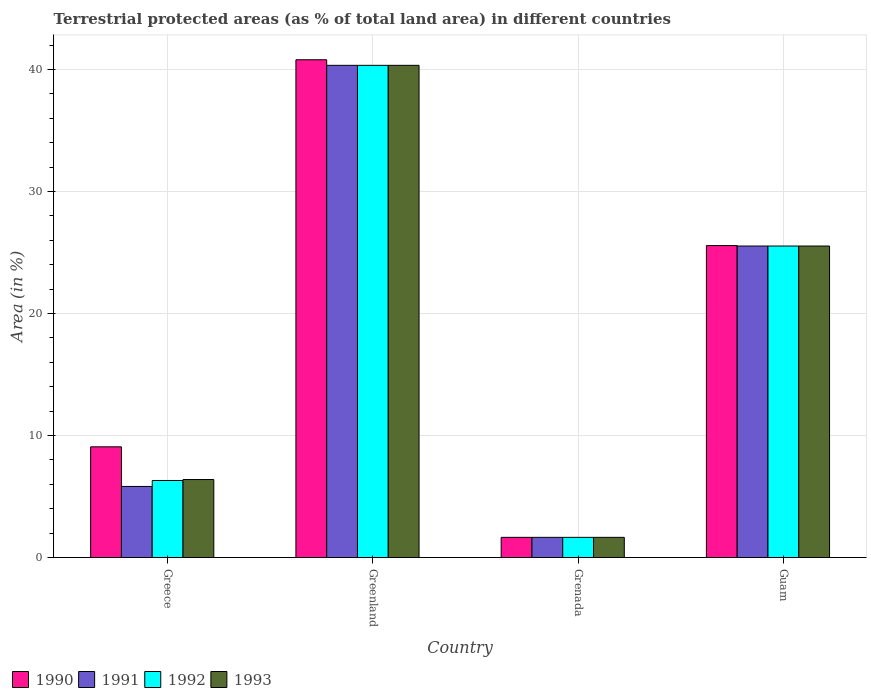How many different coloured bars are there?
Your response must be concise. 4. Are the number of bars per tick equal to the number of legend labels?
Provide a succinct answer. Yes. What is the label of the 4th group of bars from the left?
Your answer should be very brief. Guam. In how many cases, is the number of bars for a given country not equal to the number of legend labels?
Give a very brief answer. 0. What is the percentage of terrestrial protected land in 1993 in Greenland?
Offer a terse response. 40.35. Across all countries, what is the maximum percentage of terrestrial protected land in 1990?
Your answer should be very brief. 40.81. Across all countries, what is the minimum percentage of terrestrial protected land in 1991?
Offer a very short reply. 1.66. In which country was the percentage of terrestrial protected land in 1993 maximum?
Offer a terse response. Greenland. In which country was the percentage of terrestrial protected land in 1993 minimum?
Give a very brief answer. Grenada. What is the total percentage of terrestrial protected land in 1993 in the graph?
Make the answer very short. 73.94. What is the difference between the percentage of terrestrial protected land in 1991 in Greece and that in Greenland?
Offer a very short reply. -34.52. What is the difference between the percentage of terrestrial protected land in 1990 in Greece and the percentage of terrestrial protected land in 1992 in Greenland?
Provide a short and direct response. -31.27. What is the average percentage of terrestrial protected land in 1992 per country?
Make the answer very short. 18.46. What is the difference between the percentage of terrestrial protected land of/in 1993 and percentage of terrestrial protected land of/in 1992 in Guam?
Provide a succinct answer. 0. What is the ratio of the percentage of terrestrial protected land in 1991 in Greece to that in Greenland?
Ensure brevity in your answer.  0.14. What is the difference between the highest and the second highest percentage of terrestrial protected land in 1993?
Offer a terse response. 14.81. What is the difference between the highest and the lowest percentage of terrestrial protected land in 1993?
Provide a succinct answer. 38.69. What does the 1st bar from the left in Greece represents?
Your answer should be compact. 1990. What does the 4th bar from the right in Greece represents?
Your answer should be compact. 1990. Is it the case that in every country, the sum of the percentage of terrestrial protected land in 1990 and percentage of terrestrial protected land in 1993 is greater than the percentage of terrestrial protected land in 1992?
Offer a very short reply. Yes. How many bars are there?
Ensure brevity in your answer.  16. Are all the bars in the graph horizontal?
Offer a very short reply. No. Where does the legend appear in the graph?
Ensure brevity in your answer.  Bottom left. How are the legend labels stacked?
Provide a short and direct response. Horizontal. What is the title of the graph?
Offer a terse response. Terrestrial protected areas (as % of total land area) in different countries. Does "1965" appear as one of the legend labels in the graph?
Your answer should be very brief. No. What is the label or title of the X-axis?
Give a very brief answer. Country. What is the label or title of the Y-axis?
Make the answer very short. Area (in %). What is the Area (in %) of 1990 in Greece?
Your answer should be compact. 9.08. What is the Area (in %) in 1991 in Greece?
Provide a short and direct response. 5.83. What is the Area (in %) in 1992 in Greece?
Make the answer very short. 6.32. What is the Area (in %) of 1993 in Greece?
Make the answer very short. 6.4. What is the Area (in %) in 1990 in Greenland?
Your answer should be very brief. 40.81. What is the Area (in %) of 1991 in Greenland?
Offer a terse response. 40.35. What is the Area (in %) in 1992 in Greenland?
Offer a terse response. 40.35. What is the Area (in %) of 1993 in Greenland?
Your response must be concise. 40.35. What is the Area (in %) of 1990 in Grenada?
Keep it short and to the point. 1.66. What is the Area (in %) of 1991 in Grenada?
Your answer should be compact. 1.66. What is the Area (in %) in 1992 in Grenada?
Keep it short and to the point. 1.66. What is the Area (in %) in 1993 in Grenada?
Make the answer very short. 1.66. What is the Area (in %) in 1990 in Guam?
Your response must be concise. 25.57. What is the Area (in %) in 1991 in Guam?
Offer a very short reply. 25.54. What is the Area (in %) of 1992 in Guam?
Provide a short and direct response. 25.54. What is the Area (in %) in 1993 in Guam?
Provide a succinct answer. 25.54. Across all countries, what is the maximum Area (in %) in 1990?
Keep it short and to the point. 40.81. Across all countries, what is the maximum Area (in %) of 1991?
Your response must be concise. 40.35. Across all countries, what is the maximum Area (in %) in 1992?
Give a very brief answer. 40.35. Across all countries, what is the maximum Area (in %) of 1993?
Your response must be concise. 40.35. Across all countries, what is the minimum Area (in %) in 1990?
Your response must be concise. 1.66. Across all countries, what is the minimum Area (in %) in 1991?
Offer a very short reply. 1.66. Across all countries, what is the minimum Area (in %) in 1992?
Your answer should be very brief. 1.66. Across all countries, what is the minimum Area (in %) in 1993?
Your answer should be very brief. 1.66. What is the total Area (in %) in 1990 in the graph?
Offer a very short reply. 77.11. What is the total Area (in %) of 1991 in the graph?
Your response must be concise. 73.37. What is the total Area (in %) of 1992 in the graph?
Your answer should be very brief. 73.86. What is the total Area (in %) of 1993 in the graph?
Keep it short and to the point. 73.94. What is the difference between the Area (in %) in 1990 in Greece and that in Greenland?
Your answer should be very brief. -31.73. What is the difference between the Area (in %) of 1991 in Greece and that in Greenland?
Give a very brief answer. -34.52. What is the difference between the Area (in %) of 1992 in Greece and that in Greenland?
Keep it short and to the point. -34.03. What is the difference between the Area (in %) in 1993 in Greece and that in Greenland?
Offer a terse response. -33.95. What is the difference between the Area (in %) in 1990 in Greece and that in Grenada?
Ensure brevity in your answer.  7.42. What is the difference between the Area (in %) of 1991 in Greece and that in Grenada?
Your answer should be very brief. 4.17. What is the difference between the Area (in %) of 1992 in Greece and that in Grenada?
Make the answer very short. 4.66. What is the difference between the Area (in %) of 1993 in Greece and that in Grenada?
Provide a short and direct response. 4.74. What is the difference between the Area (in %) in 1990 in Greece and that in Guam?
Keep it short and to the point. -16.5. What is the difference between the Area (in %) in 1991 in Greece and that in Guam?
Offer a terse response. -19.71. What is the difference between the Area (in %) of 1992 in Greece and that in Guam?
Provide a short and direct response. -19.22. What is the difference between the Area (in %) in 1993 in Greece and that in Guam?
Offer a very short reply. -19.14. What is the difference between the Area (in %) in 1990 in Greenland and that in Grenada?
Provide a short and direct response. 39.15. What is the difference between the Area (in %) in 1991 in Greenland and that in Grenada?
Ensure brevity in your answer.  38.69. What is the difference between the Area (in %) of 1992 in Greenland and that in Grenada?
Your answer should be compact. 38.69. What is the difference between the Area (in %) in 1993 in Greenland and that in Grenada?
Make the answer very short. 38.69. What is the difference between the Area (in %) of 1990 in Greenland and that in Guam?
Your answer should be very brief. 15.23. What is the difference between the Area (in %) of 1991 in Greenland and that in Guam?
Your answer should be very brief. 14.81. What is the difference between the Area (in %) of 1992 in Greenland and that in Guam?
Offer a very short reply. 14.81. What is the difference between the Area (in %) in 1993 in Greenland and that in Guam?
Keep it short and to the point. 14.81. What is the difference between the Area (in %) in 1990 in Grenada and that in Guam?
Offer a very short reply. -23.92. What is the difference between the Area (in %) in 1991 in Grenada and that in Guam?
Your answer should be compact. -23.88. What is the difference between the Area (in %) in 1992 in Grenada and that in Guam?
Your answer should be compact. -23.88. What is the difference between the Area (in %) in 1993 in Grenada and that in Guam?
Provide a short and direct response. -23.88. What is the difference between the Area (in %) of 1990 in Greece and the Area (in %) of 1991 in Greenland?
Give a very brief answer. -31.27. What is the difference between the Area (in %) of 1990 in Greece and the Area (in %) of 1992 in Greenland?
Your response must be concise. -31.27. What is the difference between the Area (in %) in 1990 in Greece and the Area (in %) in 1993 in Greenland?
Provide a succinct answer. -31.27. What is the difference between the Area (in %) in 1991 in Greece and the Area (in %) in 1992 in Greenland?
Your answer should be very brief. -34.52. What is the difference between the Area (in %) in 1991 in Greece and the Area (in %) in 1993 in Greenland?
Your answer should be very brief. -34.52. What is the difference between the Area (in %) of 1992 in Greece and the Area (in %) of 1993 in Greenland?
Give a very brief answer. -34.03. What is the difference between the Area (in %) of 1990 in Greece and the Area (in %) of 1991 in Grenada?
Offer a very short reply. 7.42. What is the difference between the Area (in %) of 1990 in Greece and the Area (in %) of 1992 in Grenada?
Provide a short and direct response. 7.42. What is the difference between the Area (in %) of 1990 in Greece and the Area (in %) of 1993 in Grenada?
Provide a short and direct response. 7.42. What is the difference between the Area (in %) in 1991 in Greece and the Area (in %) in 1992 in Grenada?
Provide a short and direct response. 4.17. What is the difference between the Area (in %) in 1991 in Greece and the Area (in %) in 1993 in Grenada?
Offer a terse response. 4.17. What is the difference between the Area (in %) in 1992 in Greece and the Area (in %) in 1993 in Grenada?
Your answer should be compact. 4.66. What is the difference between the Area (in %) in 1990 in Greece and the Area (in %) in 1991 in Guam?
Ensure brevity in your answer.  -16.46. What is the difference between the Area (in %) of 1990 in Greece and the Area (in %) of 1992 in Guam?
Offer a terse response. -16.46. What is the difference between the Area (in %) of 1990 in Greece and the Area (in %) of 1993 in Guam?
Provide a succinct answer. -16.46. What is the difference between the Area (in %) in 1991 in Greece and the Area (in %) in 1992 in Guam?
Your answer should be very brief. -19.71. What is the difference between the Area (in %) in 1991 in Greece and the Area (in %) in 1993 in Guam?
Offer a terse response. -19.71. What is the difference between the Area (in %) of 1992 in Greece and the Area (in %) of 1993 in Guam?
Keep it short and to the point. -19.22. What is the difference between the Area (in %) in 1990 in Greenland and the Area (in %) in 1991 in Grenada?
Offer a terse response. 39.15. What is the difference between the Area (in %) in 1990 in Greenland and the Area (in %) in 1992 in Grenada?
Your answer should be very brief. 39.15. What is the difference between the Area (in %) in 1990 in Greenland and the Area (in %) in 1993 in Grenada?
Keep it short and to the point. 39.15. What is the difference between the Area (in %) of 1991 in Greenland and the Area (in %) of 1992 in Grenada?
Your answer should be compact. 38.69. What is the difference between the Area (in %) in 1991 in Greenland and the Area (in %) in 1993 in Grenada?
Give a very brief answer. 38.69. What is the difference between the Area (in %) of 1992 in Greenland and the Area (in %) of 1993 in Grenada?
Your answer should be very brief. 38.69. What is the difference between the Area (in %) of 1990 in Greenland and the Area (in %) of 1991 in Guam?
Your answer should be compact. 15.27. What is the difference between the Area (in %) in 1990 in Greenland and the Area (in %) in 1992 in Guam?
Your answer should be compact. 15.27. What is the difference between the Area (in %) in 1990 in Greenland and the Area (in %) in 1993 in Guam?
Offer a very short reply. 15.27. What is the difference between the Area (in %) in 1991 in Greenland and the Area (in %) in 1992 in Guam?
Your response must be concise. 14.81. What is the difference between the Area (in %) in 1991 in Greenland and the Area (in %) in 1993 in Guam?
Your response must be concise. 14.81. What is the difference between the Area (in %) in 1992 in Greenland and the Area (in %) in 1993 in Guam?
Ensure brevity in your answer.  14.81. What is the difference between the Area (in %) of 1990 in Grenada and the Area (in %) of 1991 in Guam?
Provide a short and direct response. -23.88. What is the difference between the Area (in %) in 1990 in Grenada and the Area (in %) in 1992 in Guam?
Give a very brief answer. -23.88. What is the difference between the Area (in %) of 1990 in Grenada and the Area (in %) of 1993 in Guam?
Give a very brief answer. -23.88. What is the difference between the Area (in %) of 1991 in Grenada and the Area (in %) of 1992 in Guam?
Provide a short and direct response. -23.88. What is the difference between the Area (in %) of 1991 in Grenada and the Area (in %) of 1993 in Guam?
Give a very brief answer. -23.88. What is the difference between the Area (in %) in 1992 in Grenada and the Area (in %) in 1993 in Guam?
Make the answer very short. -23.88. What is the average Area (in %) in 1990 per country?
Keep it short and to the point. 19.28. What is the average Area (in %) of 1991 per country?
Provide a short and direct response. 18.34. What is the average Area (in %) of 1992 per country?
Provide a short and direct response. 18.46. What is the average Area (in %) in 1993 per country?
Ensure brevity in your answer.  18.48. What is the difference between the Area (in %) in 1990 and Area (in %) in 1991 in Greece?
Provide a succinct answer. 3.25. What is the difference between the Area (in %) in 1990 and Area (in %) in 1992 in Greece?
Your answer should be very brief. 2.76. What is the difference between the Area (in %) of 1990 and Area (in %) of 1993 in Greece?
Provide a short and direct response. 2.68. What is the difference between the Area (in %) of 1991 and Area (in %) of 1992 in Greece?
Provide a succinct answer. -0.49. What is the difference between the Area (in %) in 1991 and Area (in %) in 1993 in Greece?
Keep it short and to the point. -0.57. What is the difference between the Area (in %) of 1992 and Area (in %) of 1993 in Greece?
Keep it short and to the point. -0.08. What is the difference between the Area (in %) of 1990 and Area (in %) of 1991 in Greenland?
Keep it short and to the point. 0.46. What is the difference between the Area (in %) in 1990 and Area (in %) in 1992 in Greenland?
Give a very brief answer. 0.46. What is the difference between the Area (in %) of 1990 and Area (in %) of 1993 in Greenland?
Your answer should be very brief. 0.46. What is the difference between the Area (in %) of 1991 and Area (in %) of 1992 in Greenland?
Offer a terse response. 0. What is the difference between the Area (in %) of 1991 and Area (in %) of 1993 in Greenland?
Make the answer very short. 0. What is the difference between the Area (in %) of 1990 and Area (in %) of 1991 in Grenada?
Offer a terse response. 0. What is the difference between the Area (in %) of 1992 and Area (in %) of 1993 in Grenada?
Your response must be concise. 0. What is the difference between the Area (in %) in 1990 and Area (in %) in 1991 in Guam?
Your answer should be compact. 0.04. What is the difference between the Area (in %) in 1990 and Area (in %) in 1992 in Guam?
Keep it short and to the point. 0.04. What is the difference between the Area (in %) of 1990 and Area (in %) of 1993 in Guam?
Keep it short and to the point. 0.04. What is the difference between the Area (in %) in 1991 and Area (in %) in 1992 in Guam?
Ensure brevity in your answer.  0. What is the difference between the Area (in %) in 1992 and Area (in %) in 1993 in Guam?
Keep it short and to the point. 0. What is the ratio of the Area (in %) of 1990 in Greece to that in Greenland?
Offer a very short reply. 0.22. What is the ratio of the Area (in %) of 1991 in Greece to that in Greenland?
Your answer should be very brief. 0.14. What is the ratio of the Area (in %) of 1992 in Greece to that in Greenland?
Offer a terse response. 0.16. What is the ratio of the Area (in %) of 1993 in Greece to that in Greenland?
Your response must be concise. 0.16. What is the ratio of the Area (in %) in 1990 in Greece to that in Grenada?
Your response must be concise. 5.48. What is the ratio of the Area (in %) of 1991 in Greece to that in Grenada?
Offer a very short reply. 3.52. What is the ratio of the Area (in %) of 1992 in Greece to that in Grenada?
Provide a succinct answer. 3.82. What is the ratio of the Area (in %) of 1993 in Greece to that in Grenada?
Your answer should be compact. 3.86. What is the ratio of the Area (in %) of 1990 in Greece to that in Guam?
Your answer should be very brief. 0.35. What is the ratio of the Area (in %) in 1991 in Greece to that in Guam?
Make the answer very short. 0.23. What is the ratio of the Area (in %) of 1992 in Greece to that in Guam?
Your response must be concise. 0.25. What is the ratio of the Area (in %) of 1993 in Greece to that in Guam?
Offer a terse response. 0.25. What is the ratio of the Area (in %) in 1990 in Greenland to that in Grenada?
Ensure brevity in your answer.  24.65. What is the ratio of the Area (in %) of 1991 in Greenland to that in Grenada?
Offer a terse response. 24.38. What is the ratio of the Area (in %) of 1992 in Greenland to that in Grenada?
Give a very brief answer. 24.38. What is the ratio of the Area (in %) of 1993 in Greenland to that in Grenada?
Offer a very short reply. 24.38. What is the ratio of the Area (in %) in 1990 in Greenland to that in Guam?
Your answer should be very brief. 1.6. What is the ratio of the Area (in %) of 1991 in Greenland to that in Guam?
Offer a terse response. 1.58. What is the ratio of the Area (in %) in 1992 in Greenland to that in Guam?
Offer a terse response. 1.58. What is the ratio of the Area (in %) of 1993 in Greenland to that in Guam?
Give a very brief answer. 1.58. What is the ratio of the Area (in %) in 1990 in Grenada to that in Guam?
Make the answer very short. 0.06. What is the ratio of the Area (in %) of 1991 in Grenada to that in Guam?
Offer a very short reply. 0.06. What is the ratio of the Area (in %) of 1992 in Grenada to that in Guam?
Provide a succinct answer. 0.06. What is the ratio of the Area (in %) in 1993 in Grenada to that in Guam?
Offer a very short reply. 0.06. What is the difference between the highest and the second highest Area (in %) of 1990?
Ensure brevity in your answer.  15.23. What is the difference between the highest and the second highest Area (in %) in 1991?
Ensure brevity in your answer.  14.81. What is the difference between the highest and the second highest Area (in %) of 1992?
Ensure brevity in your answer.  14.81. What is the difference between the highest and the second highest Area (in %) in 1993?
Your answer should be compact. 14.81. What is the difference between the highest and the lowest Area (in %) of 1990?
Ensure brevity in your answer.  39.15. What is the difference between the highest and the lowest Area (in %) in 1991?
Offer a terse response. 38.69. What is the difference between the highest and the lowest Area (in %) of 1992?
Give a very brief answer. 38.69. What is the difference between the highest and the lowest Area (in %) of 1993?
Provide a succinct answer. 38.69. 